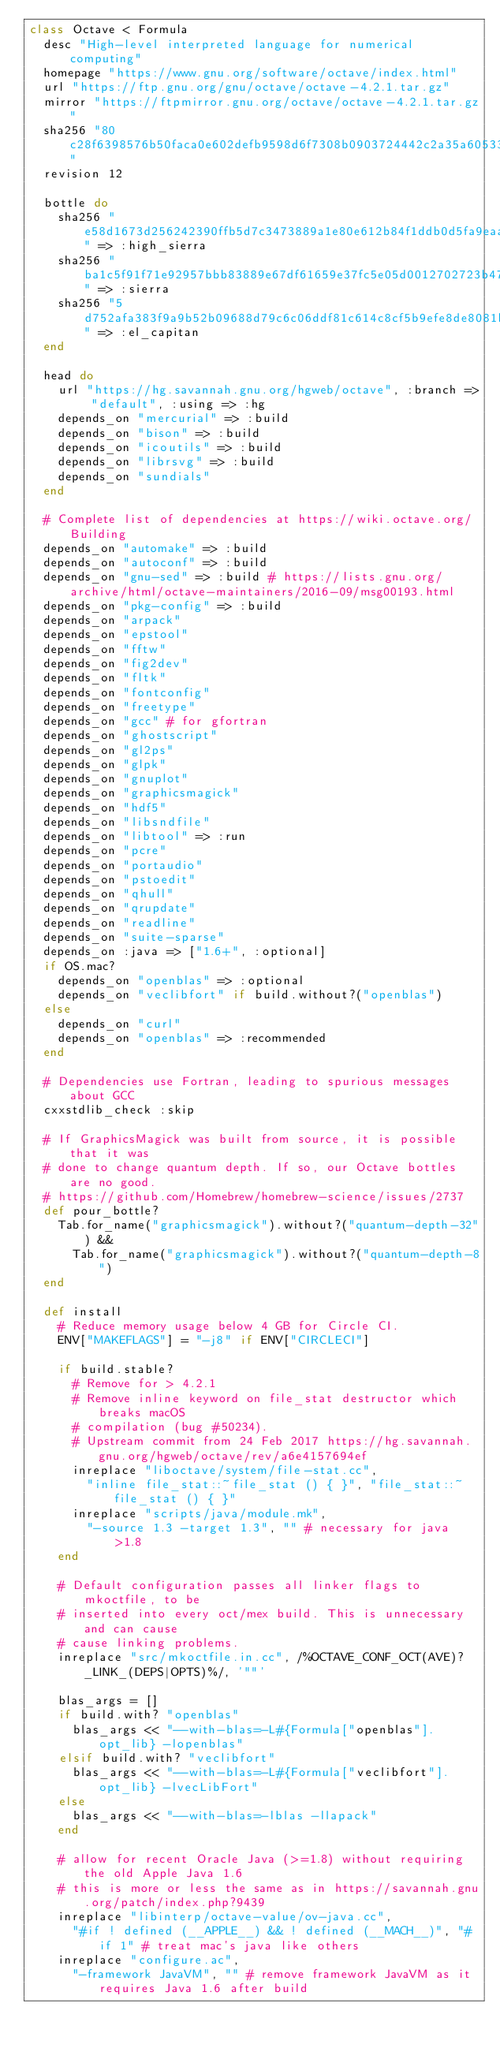<code> <loc_0><loc_0><loc_500><loc_500><_Ruby_>class Octave < Formula
  desc "High-level interpreted language for numerical computing"
  homepage "https://www.gnu.org/software/octave/index.html"
  url "https://ftp.gnu.org/gnu/octave/octave-4.2.1.tar.gz"
  mirror "https://ftpmirror.gnu.org/octave/octave-4.2.1.tar.gz"
  sha256 "80c28f6398576b50faca0e602defb9598d6f7308b0903724442c2a35a605333b"
  revision 12

  bottle do
    sha256 "e58d1673d256242390ffb5d7c3473889a1e80e612b84f1ddb0d5fa9eaa00d63c" => :high_sierra
    sha256 "ba1c5f91f71e92957bbb83889e67df61659e37fc5e05d0012702723b47a7d182" => :sierra
    sha256 "5d752afa383f9a9b52b09688d79c6c06ddf81c614c8cf5b9efe8de8081b7b8f9" => :el_capitan
  end

  head do
    url "https://hg.savannah.gnu.org/hgweb/octave", :branch => "default", :using => :hg
    depends_on "mercurial" => :build
    depends_on "bison" => :build
    depends_on "icoutils" => :build
    depends_on "librsvg" => :build
    depends_on "sundials"
  end

  # Complete list of dependencies at https://wiki.octave.org/Building
  depends_on "automake" => :build
  depends_on "autoconf" => :build
  depends_on "gnu-sed" => :build # https://lists.gnu.org/archive/html/octave-maintainers/2016-09/msg00193.html
  depends_on "pkg-config" => :build
  depends_on "arpack"
  depends_on "epstool"
  depends_on "fftw"
  depends_on "fig2dev"
  depends_on "fltk"
  depends_on "fontconfig"
  depends_on "freetype"
  depends_on "gcc" # for gfortran
  depends_on "ghostscript"
  depends_on "gl2ps"
  depends_on "glpk"
  depends_on "gnuplot"
  depends_on "graphicsmagick"
  depends_on "hdf5"
  depends_on "libsndfile"
  depends_on "libtool" => :run
  depends_on "pcre"
  depends_on "portaudio"
  depends_on "pstoedit"
  depends_on "qhull"
  depends_on "qrupdate"
  depends_on "readline"
  depends_on "suite-sparse"
  depends_on :java => ["1.6+", :optional]
  if OS.mac?
    depends_on "openblas" => :optional
    depends_on "veclibfort" if build.without?("openblas")
  else
    depends_on "curl"
    depends_on "openblas" => :recommended
  end

  # Dependencies use Fortran, leading to spurious messages about GCC
  cxxstdlib_check :skip

  # If GraphicsMagick was built from source, it is possible that it was
  # done to change quantum depth. If so, our Octave bottles are no good.
  # https://github.com/Homebrew/homebrew-science/issues/2737
  def pour_bottle?
    Tab.for_name("graphicsmagick").without?("quantum-depth-32") &&
      Tab.for_name("graphicsmagick").without?("quantum-depth-8")
  end

  def install
    # Reduce memory usage below 4 GB for Circle CI.
    ENV["MAKEFLAGS"] = "-j8" if ENV["CIRCLECI"]

    if build.stable?
      # Remove for > 4.2.1
      # Remove inline keyword on file_stat destructor which breaks macOS
      # compilation (bug #50234).
      # Upstream commit from 24 Feb 2017 https://hg.savannah.gnu.org/hgweb/octave/rev/a6e4157694ef
      inreplace "liboctave/system/file-stat.cc",
        "inline file_stat::~file_stat () { }", "file_stat::~file_stat () { }"
      inreplace "scripts/java/module.mk",
        "-source 1.3 -target 1.3", "" # necessary for java >1.8
    end

    # Default configuration passes all linker flags to mkoctfile, to be
    # inserted into every oct/mex build. This is unnecessary and can cause
    # cause linking problems.
    inreplace "src/mkoctfile.in.cc", /%OCTAVE_CONF_OCT(AVE)?_LINK_(DEPS|OPTS)%/, '""'

    blas_args = []
    if build.with? "openblas"
      blas_args << "--with-blas=-L#{Formula["openblas"].opt_lib} -lopenblas"
    elsif build.with? "veclibfort"
      blas_args << "--with-blas=-L#{Formula["veclibfort"].opt_lib} -lvecLibFort"
    else
      blas_args << "--with-blas=-lblas -llapack"
    end

    # allow for recent Oracle Java (>=1.8) without requiring the old Apple Java 1.6
    # this is more or less the same as in https://savannah.gnu.org/patch/index.php?9439
    inreplace "libinterp/octave-value/ov-java.cc",
      "#if ! defined (__APPLE__) && ! defined (__MACH__)", "#if 1" # treat mac's java like others
    inreplace "configure.ac",
      "-framework JavaVM", "" # remove framework JavaVM as it requires Java 1.6 after build
</code> 